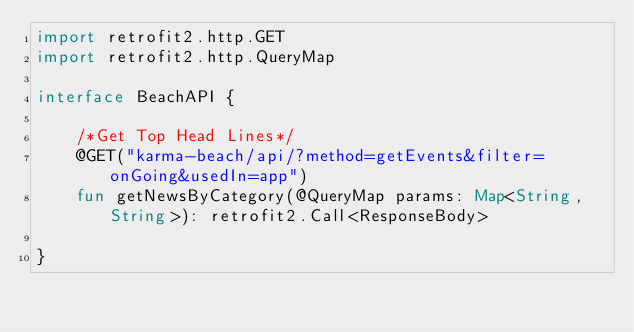Convert code to text. <code><loc_0><loc_0><loc_500><loc_500><_Kotlin_>import retrofit2.http.GET
import retrofit2.http.QueryMap

interface BeachAPI {

    /*Get Top Head Lines*/
    @GET("karma-beach/api/?method=getEvents&filter=onGoing&usedIn=app")
    fun getNewsByCategory(@QueryMap params: Map<String, String>): retrofit2.Call<ResponseBody>

}
</code> 